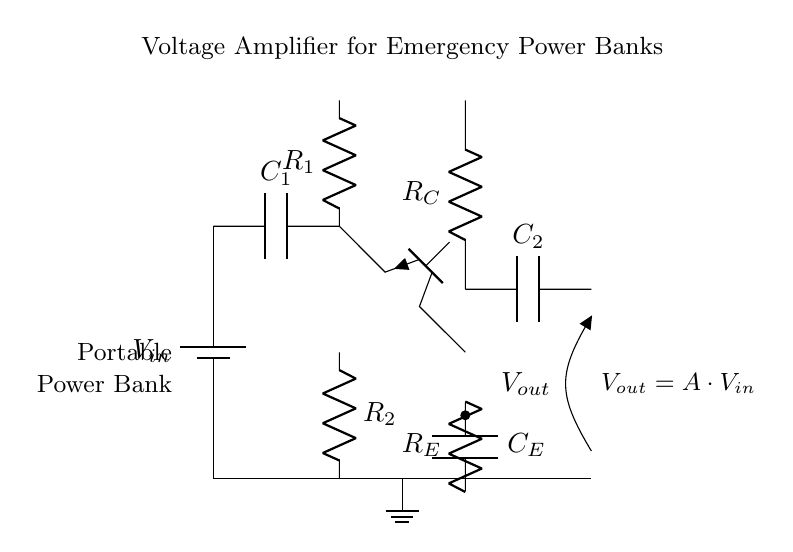What is the input voltage labeled in the circuit? The input voltage is labeled as \( V_{in} \) in the diagram. It represents the voltage supplied to the circuit and is located at the top left corner where the battery symbol is.
Answer: \( V_{in} \) What is the role of capacitor \( C_1 \)? Capacitor \( C_1 \) functions as an input capacitor, which helps in stabilizing the voltage and smoothing out fluctuations coming from the power supply. It is located directly after the input voltage source.
Answer: Input stabilization What is the purpose of resistor \( R_C \)? Resistor \( R_C \) is connected to the collector of the transistor and is used to limit the current flowing through the transistor. It plays a crucial role in determining the gain of the amplifier, which is essential for its function.
Answer: Current limiting How many resistors are present in this circuit? The circuit contains three resistors: \( R_1 \), \( R_2 \), and \( R_E \). Each of these resistors has distinct roles, such as biasing or stabilizing the amplifier.
Answer: Three What is the relationship between input voltage and output voltage in this circuit? The relationship is defined by the equation \( V_{out} = A \cdot V_{in} \), where \( A \) is the amplification factor of the amplifier. This means that the output voltage is a multiple of the input voltage based on the design of the amplifier.
Answer: Output equals input times amplification factor What type of transistor is used in this circuit? An NPN transistor is utilized in this circuit, as indicated by the label "npn" next to the transistor symbol. It is important for the functionality of the amplifier, allowing it to provide voltage gain.
Answer: NPN transistor What occurs at the output capacitor \( C_2 \)? Capacitor \( C_2 \) takes the amplified voltage output and helps to smooth it, providing a cleaner voltage signal for use in connected devices. It is positioned at the output node, after the collector resistor.
Answer: Output smoothing 